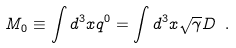<formula> <loc_0><loc_0><loc_500><loc_500>M _ { 0 } \equiv \int d ^ { 3 } x q ^ { 0 } = \int d ^ { 3 } x \sqrt { \gamma } D \ .</formula> 